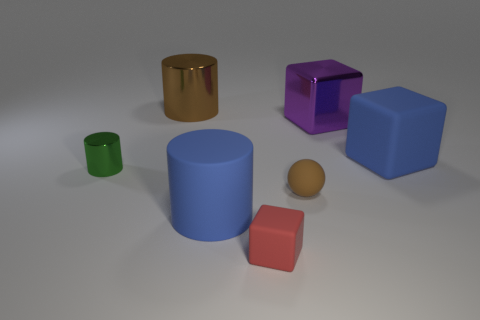Subtract all blue rubber cylinders. How many cylinders are left? 2 Subtract all red cubes. How many cubes are left? 2 Add 2 large purple shiny blocks. How many objects exist? 9 Subtract 1 blocks. How many blocks are left? 2 Subtract all spheres. How many objects are left? 6 Subtract all yellow balls. How many green cylinders are left? 1 Add 3 large blue shiny blocks. How many large blue shiny blocks exist? 3 Subtract 0 green blocks. How many objects are left? 7 Subtract all gray cylinders. Subtract all cyan balls. How many cylinders are left? 3 Subtract all yellow metallic objects. Subtract all tiny red matte blocks. How many objects are left? 6 